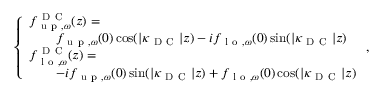Convert formula to latex. <formula><loc_0><loc_0><loc_500><loc_500>\begin{array} { r } { \left \{ \begin{array} { l l } { { f } _ { u p , \omega } ^ { D C } ( z ) = } \\ { \quad f _ { u p , \omega } ( 0 ) \cos ( | \kappa _ { D C } | z ) - i { f } _ { l o , \omega } ( 0 ) \sin ( | \kappa _ { D C } | z ) } \\ { { f } _ { l o , \omega } ^ { D C } ( z ) = } \\ { \quad - i { f } _ { u p , \omega } ( 0 ) \sin ( | \kappa _ { D C } | z ) + { f } _ { l o , \omega } ( 0 ) \cos ( | \kappa _ { D C } | z ) } \end{array} , } \end{array}</formula> 